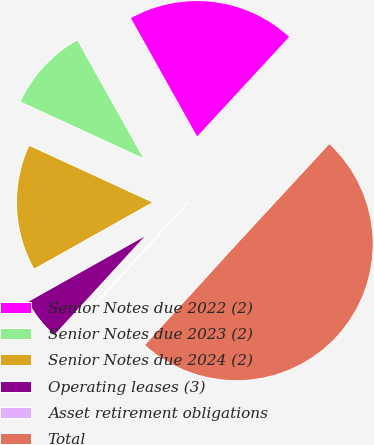Convert chart. <chart><loc_0><loc_0><loc_500><loc_500><pie_chart><fcel>Senior Notes due 2022 (2)<fcel>Senior Notes due 2023 (2)<fcel>Senior Notes due 2024 (2)<fcel>Operating leases (3)<fcel>Asset retirement obligations<fcel>Total<nl><fcel>19.99%<fcel>10.02%<fcel>15.01%<fcel>5.04%<fcel>0.06%<fcel>49.88%<nl></chart> 